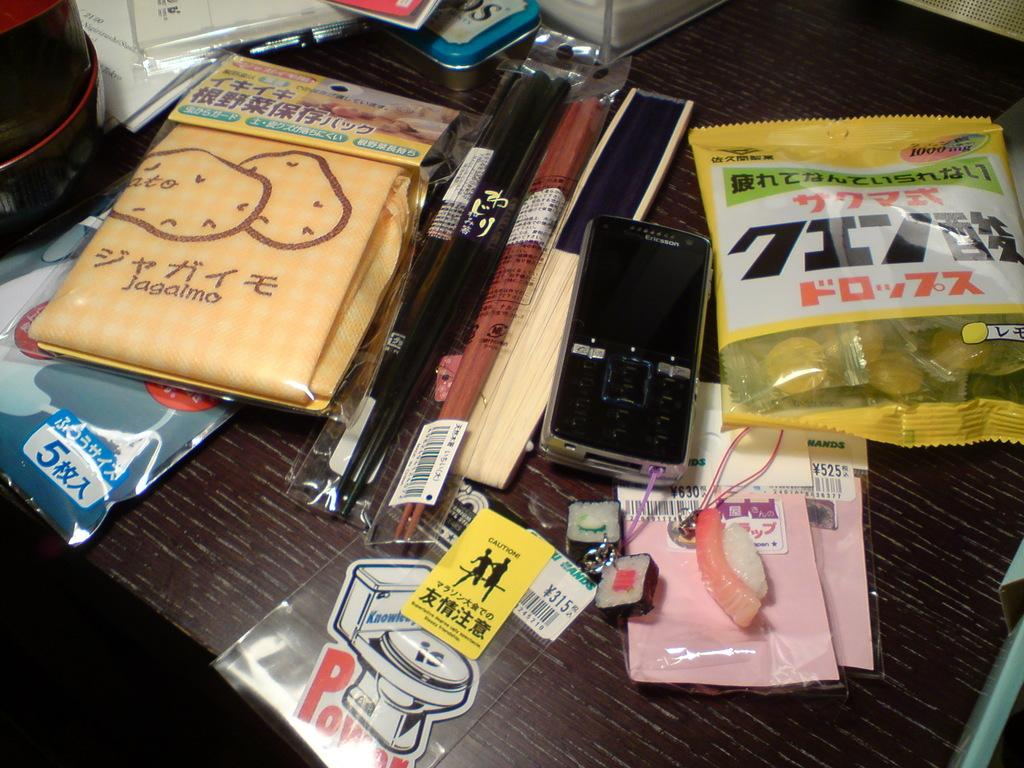Provide a one-sentence caption for the provided image. A shelf has packages on it including one that has a picture of a toilet with the word POW beneath it and a Caution sticker on the packaging. 